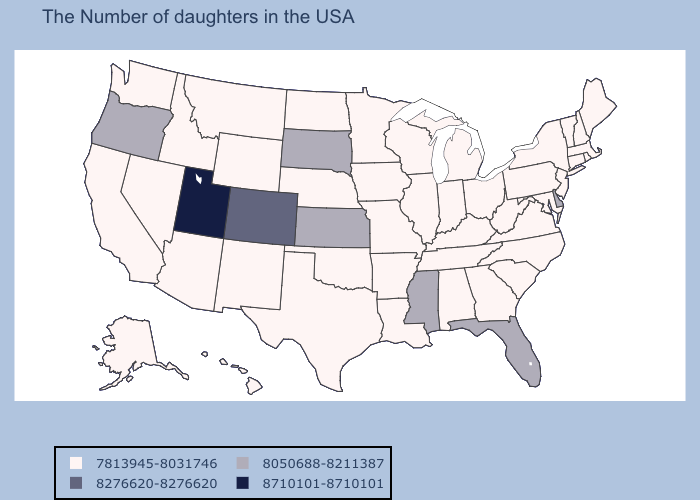Does Arkansas have the lowest value in the USA?
Concise answer only. Yes. Which states have the highest value in the USA?
Concise answer only. Utah. Does Utah have the highest value in the USA?
Answer briefly. Yes. Among the states that border Arizona , does Utah have the lowest value?
Keep it brief. No. Which states have the lowest value in the USA?
Short answer required. Maine, Massachusetts, Rhode Island, New Hampshire, Vermont, Connecticut, New York, New Jersey, Maryland, Pennsylvania, Virginia, North Carolina, South Carolina, West Virginia, Ohio, Georgia, Michigan, Kentucky, Indiana, Alabama, Tennessee, Wisconsin, Illinois, Louisiana, Missouri, Arkansas, Minnesota, Iowa, Nebraska, Oklahoma, Texas, North Dakota, Wyoming, New Mexico, Montana, Arizona, Idaho, Nevada, California, Washington, Alaska, Hawaii. How many symbols are there in the legend?
Write a very short answer. 4. What is the value of Utah?
Give a very brief answer. 8710101-8710101. What is the highest value in states that border Virginia?
Quick response, please. 7813945-8031746. What is the value of Minnesota?
Answer briefly. 7813945-8031746. Among the states that border Nebraska , which have the highest value?
Keep it brief. Colorado. What is the value of West Virginia?
Write a very short answer. 7813945-8031746. Which states hav the highest value in the MidWest?
Be succinct. Kansas, South Dakota. Does the first symbol in the legend represent the smallest category?
Give a very brief answer. Yes. What is the highest value in the USA?
Short answer required. 8710101-8710101. 